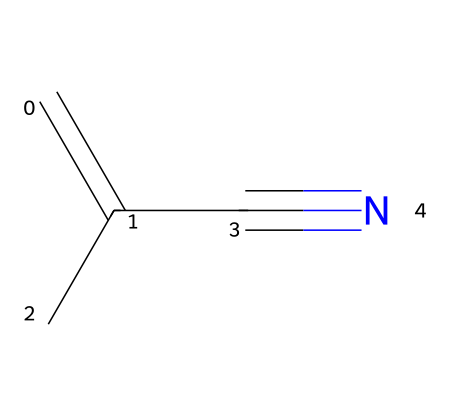What is the molecular formula of methacrylonitrile? The molecular formula can be derived from the SMILES representation, which consists of 5 carbon atoms, 7 hydrogen atoms, and 1 nitrogen atom. The formula is C5H7N.
Answer: C5H7N How many double bonds are present in the structure? By analyzing the SMILES, the “C=C” indicates one double bond exists between two carbon atoms in the structure.
Answer: 1 What functional group is present in methacrylonitrile? The SMILES ends with “C#N,” indicating the cyano group (nitrile), which is characteristic of nitriles.
Answer: cyano What type of reaction is typically used to produce methacrylonitrile? Methacrylonitrile is often produced through the addition of hydrogen cyanide to an acrylonitrile precursor, indicating an addition reaction.
Answer: addition What characteristic property does the nitrile group impart to methacrylonitrile? Nitriles, including methacrylonitrile, tend to have high polarity due to the presence of the cyano group, which significantly affects solubility and reactivity.
Answer: high polarity Can methacrylonitrile be considered a monomer? Methacrylonitrile has a vinyl group (C=C) in its structure that can participate in polymerization reactions, thus it is classified as a monomer.
Answer: yes 